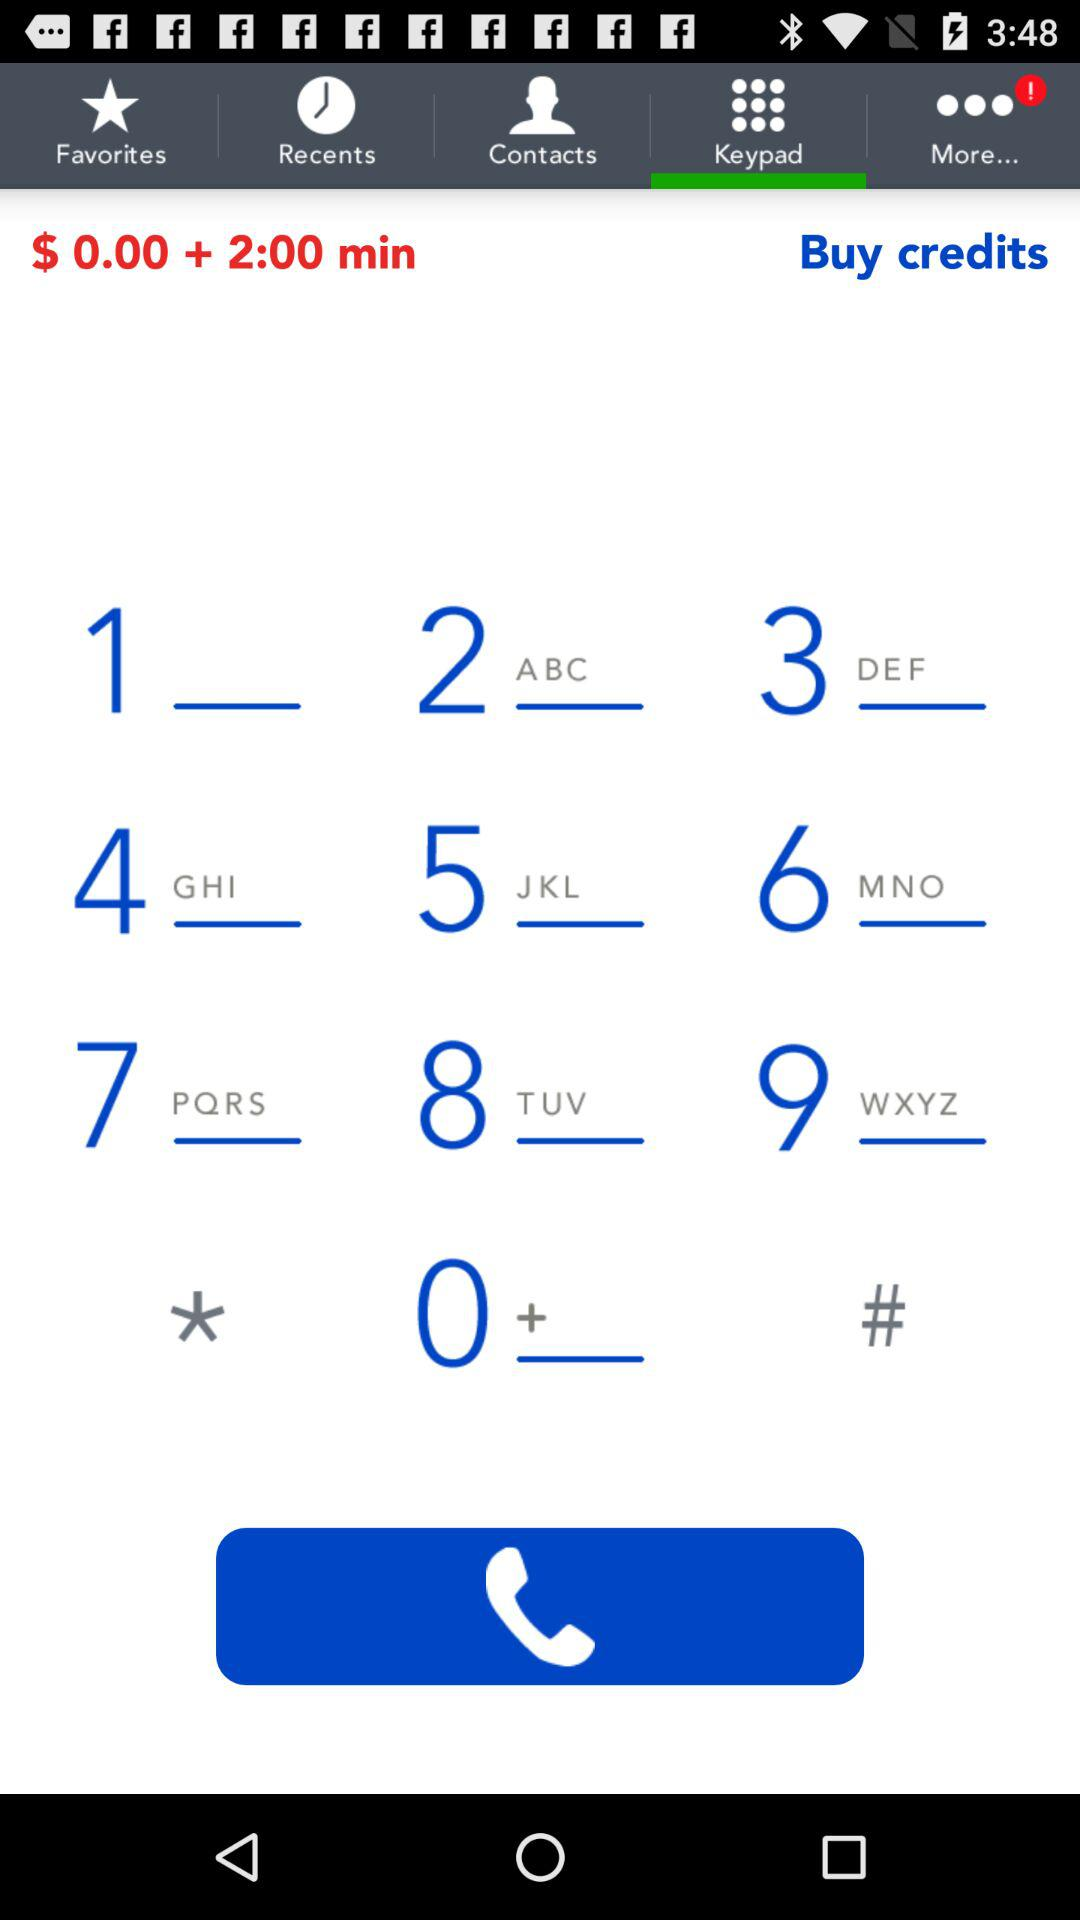Which tab is selected? The selected tab is "Keypad". 